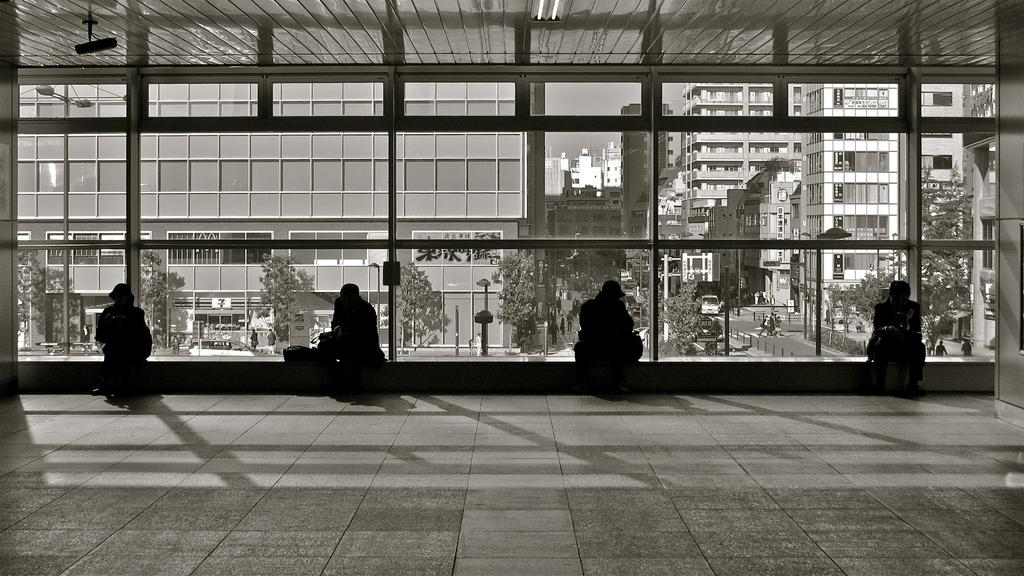How many people are sitting in the image? There are four persons sitting in the image. What can be seen in the background of the image? There are buildings, trees, and poles in the background of the image. Is there any transportation visible in the image? Yes, there is a vehicle visible in the image. What material is present in the image? There is glass present in the image. What type of bells can be heard ringing in the image? There are no bells present in the image, and therefore no sound can be heard. 